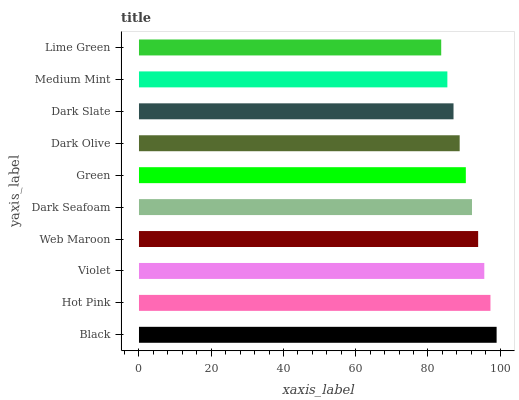Is Lime Green the minimum?
Answer yes or no. Yes. Is Black the maximum?
Answer yes or no. Yes. Is Hot Pink the minimum?
Answer yes or no. No. Is Hot Pink the maximum?
Answer yes or no. No. Is Black greater than Hot Pink?
Answer yes or no. Yes. Is Hot Pink less than Black?
Answer yes or no. Yes. Is Hot Pink greater than Black?
Answer yes or no. No. Is Black less than Hot Pink?
Answer yes or no. No. Is Dark Seafoam the high median?
Answer yes or no. Yes. Is Green the low median?
Answer yes or no. Yes. Is Hot Pink the high median?
Answer yes or no. No. Is Medium Mint the low median?
Answer yes or no. No. 